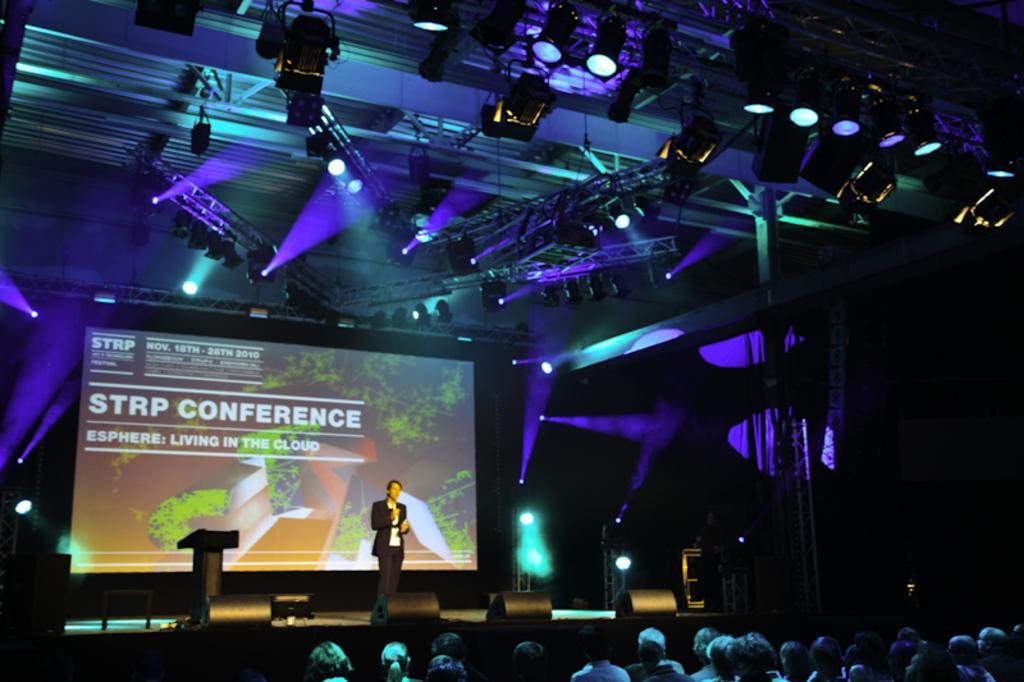Describe this image in one or two sentences. In this picture there is a man standing on the stage and we can see devices, screen, podium and lights. These are audience. At the top of the image we can see focusing lights and rods. In the background of the image it is dark. 